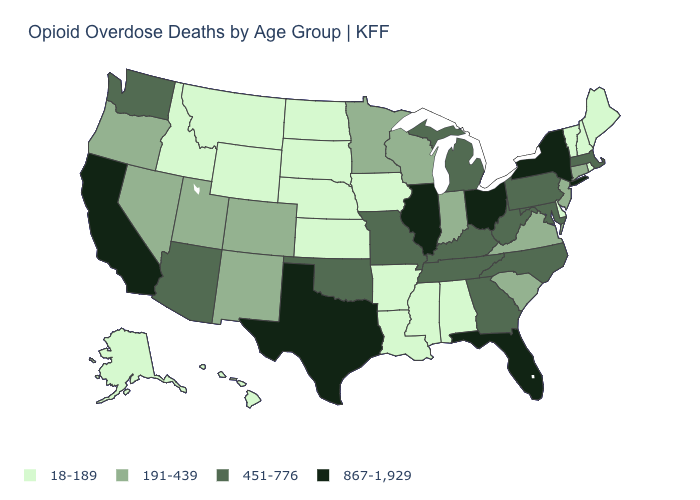Name the states that have a value in the range 867-1,929?
Answer briefly. California, Florida, Illinois, New York, Ohio, Texas. What is the value of Maryland?
Quick response, please. 451-776. Name the states that have a value in the range 191-439?
Short answer required. Colorado, Connecticut, Indiana, Minnesota, Nevada, New Jersey, New Mexico, Oregon, South Carolina, Utah, Virginia, Wisconsin. What is the value of Delaware?
Answer briefly. 18-189. Among the states that border South Carolina , which have the lowest value?
Short answer required. Georgia, North Carolina. What is the highest value in states that border Iowa?
Quick response, please. 867-1,929. What is the highest value in states that border South Dakota?
Short answer required. 191-439. Does Arizona have a higher value than Delaware?
Short answer required. Yes. What is the value of New Mexico?
Concise answer only. 191-439. Name the states that have a value in the range 18-189?
Quick response, please. Alabama, Alaska, Arkansas, Delaware, Hawaii, Idaho, Iowa, Kansas, Louisiana, Maine, Mississippi, Montana, Nebraska, New Hampshire, North Dakota, Rhode Island, South Dakota, Vermont, Wyoming. Does the first symbol in the legend represent the smallest category?
Answer briefly. Yes. Among the states that border Indiana , which have the lowest value?
Give a very brief answer. Kentucky, Michigan. Among the states that border Wyoming , which have the highest value?
Answer briefly. Colorado, Utah. What is the value of Nevada?
Concise answer only. 191-439. Which states have the lowest value in the USA?
Write a very short answer. Alabama, Alaska, Arkansas, Delaware, Hawaii, Idaho, Iowa, Kansas, Louisiana, Maine, Mississippi, Montana, Nebraska, New Hampshire, North Dakota, Rhode Island, South Dakota, Vermont, Wyoming. 